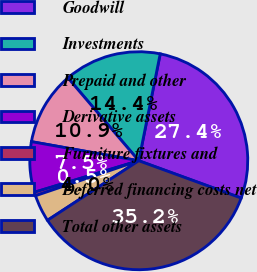Convert chart. <chart><loc_0><loc_0><loc_500><loc_500><pie_chart><fcel>Goodwill<fcel>Investments<fcel>Prepaid and other<fcel>Derivative assets<fcel>Furniture fixtures and<fcel>Deferred financing costs net<fcel>Total other assets<nl><fcel>27.4%<fcel>14.41%<fcel>10.94%<fcel>7.47%<fcel>0.53%<fcel>4.0%<fcel>35.23%<nl></chart> 